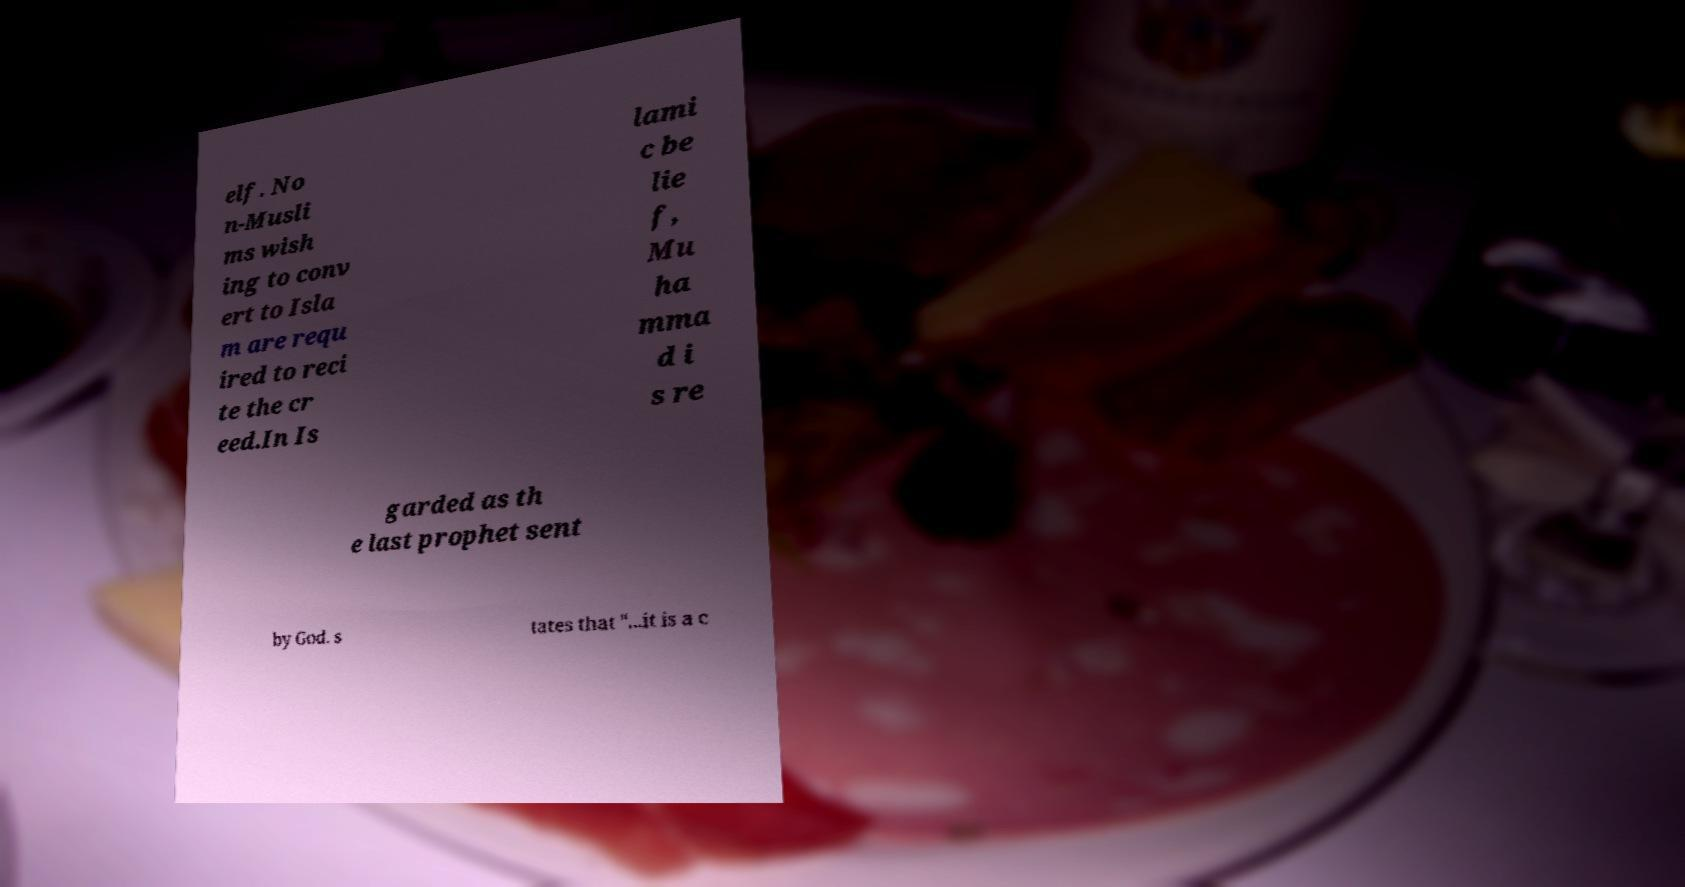Please read and relay the text visible in this image. What does it say? elf. No n-Musli ms wish ing to conv ert to Isla m are requ ired to reci te the cr eed.In Is lami c be lie f, Mu ha mma d i s re garded as th e last prophet sent by God. s tates that "...it is a c 